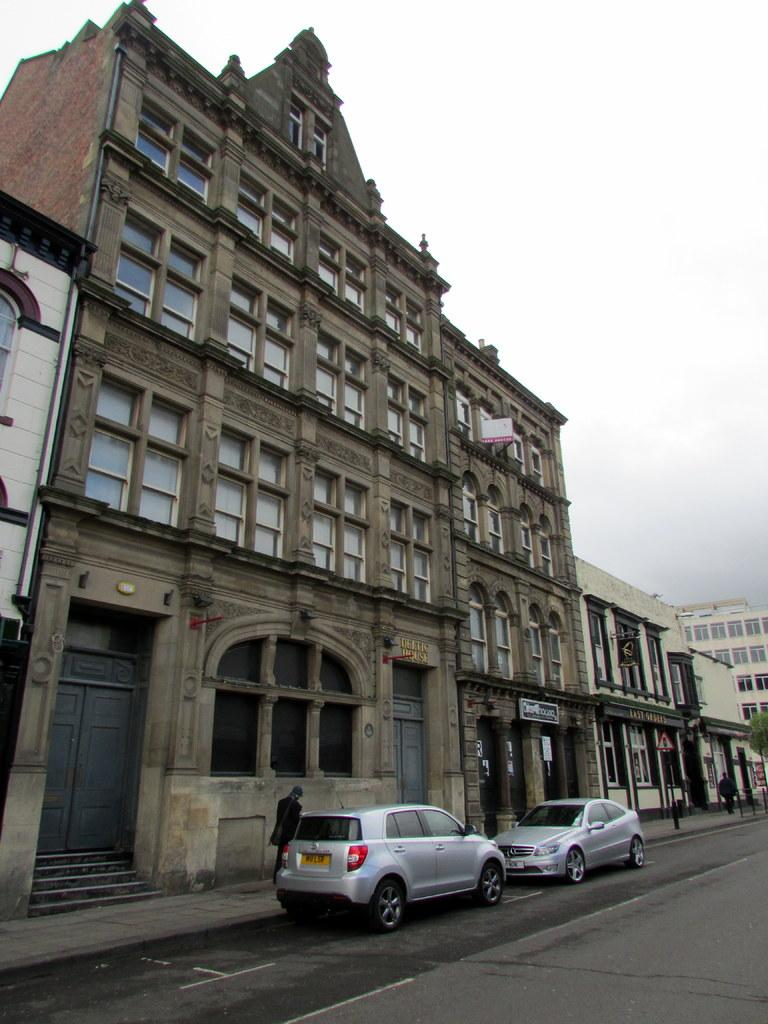How many cars are visible on the road in the image? There are two cars on the road in the image. What can be seen in the background of the image? There are buildings, poles, boards, and the sky visible in the background of the image. What type of prose is written on the pot in the image? There is no pot or prose present in the image. How many balloons are tied to the car in the image? There are no balloons visible in the image; only two cars, buildings, poles, boards, and the sky are present. 